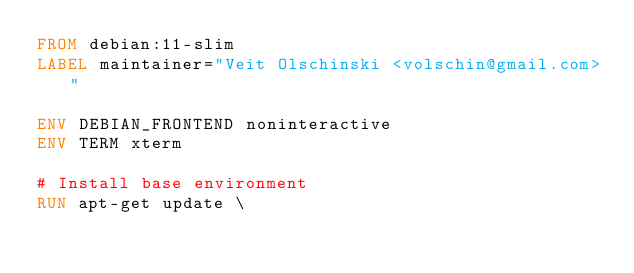<code> <loc_0><loc_0><loc_500><loc_500><_Dockerfile_>FROM debian:11-slim
LABEL maintainer="Veit Olschinski <volschin@gmail.com>"

ENV DEBIAN_FRONTEND noninteractive
ENV TERM xterm

# Install base environment
RUN apt-get update \</code> 